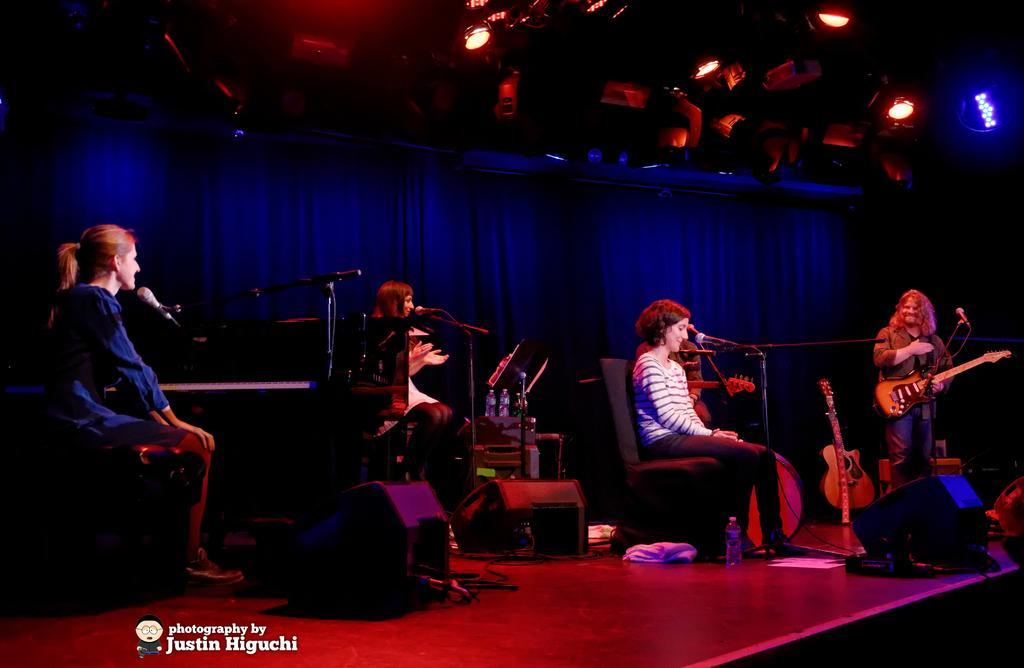In one or two sentences, can you explain what this image depicts? As we can see in the image, there are four people on stage. These three people are sitting and the man who is standing on the right side is holding guitar in his hand and there are mics on stage. 